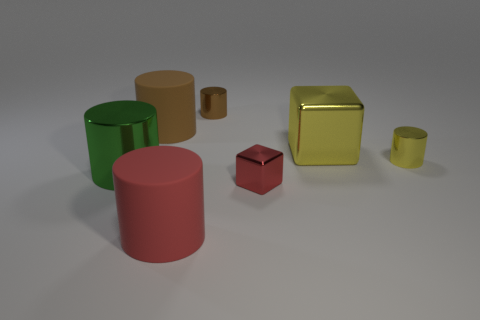Do the block that is behind the big metal cylinder and the big brown thing have the same material?
Your response must be concise. No. Are there any other big metal things of the same shape as the green thing?
Make the answer very short. No. There is a large rubber cylinder in front of the large shiny thing on the right side of the small metal thing in front of the large green thing; what color is it?
Your response must be concise. Red. How many matte objects are either tiny brown objects or blue balls?
Your answer should be very brief. 0. Is the number of large metal things left of the large red matte thing greater than the number of large red objects on the right side of the red metal block?
Provide a short and direct response. Yes. How many other objects are there of the same size as the red metallic thing?
Provide a succinct answer. 2. How big is the red object on the right side of the cylinder behind the big brown thing?
Give a very brief answer. Small. What number of tiny objects are red objects or green things?
Ensure brevity in your answer.  1. What size is the brown thing on the right side of the matte cylinder that is right of the large matte cylinder behind the big cube?
Ensure brevity in your answer.  Small. Is there any other thing that is the same color as the big metallic cylinder?
Offer a terse response. No. 